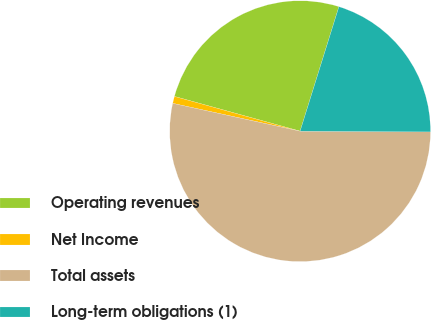<chart> <loc_0><loc_0><loc_500><loc_500><pie_chart><fcel>Operating revenues<fcel>Net Income<fcel>Total assets<fcel>Long-term obligations (1)<nl><fcel>25.52%<fcel>0.87%<fcel>53.33%<fcel>20.28%<nl></chart> 